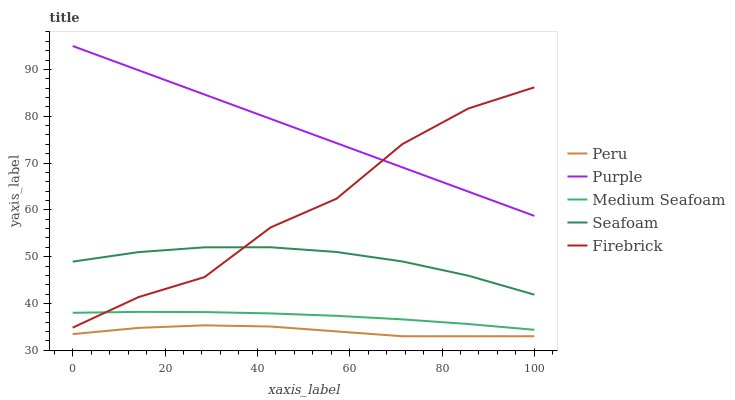Does Peru have the minimum area under the curve?
Answer yes or no. Yes. Does Purple have the maximum area under the curve?
Answer yes or no. Yes. Does Firebrick have the minimum area under the curve?
Answer yes or no. No. Does Firebrick have the maximum area under the curve?
Answer yes or no. No. Is Purple the smoothest?
Answer yes or no. Yes. Is Firebrick the roughest?
Answer yes or no. Yes. Is Medium Seafoam the smoothest?
Answer yes or no. No. Is Medium Seafoam the roughest?
Answer yes or no. No. Does Peru have the lowest value?
Answer yes or no. Yes. Does Firebrick have the lowest value?
Answer yes or no. No. Does Purple have the highest value?
Answer yes or no. Yes. Does Firebrick have the highest value?
Answer yes or no. No. Is Seafoam less than Purple?
Answer yes or no. Yes. Is Purple greater than Peru?
Answer yes or no. Yes. Does Purple intersect Firebrick?
Answer yes or no. Yes. Is Purple less than Firebrick?
Answer yes or no. No. Is Purple greater than Firebrick?
Answer yes or no. No. Does Seafoam intersect Purple?
Answer yes or no. No. 